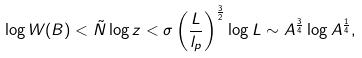<formula> <loc_0><loc_0><loc_500><loc_500>\log W ( B ) < \tilde { N } \log z < \sigma \left ( \frac { L } { l _ { p } } \right ) ^ { \frac { 3 } { 2 } } \log L \sim A ^ { \frac { 3 } { 4 } } \log A ^ { \frac { 1 } { 4 } } ,</formula> 